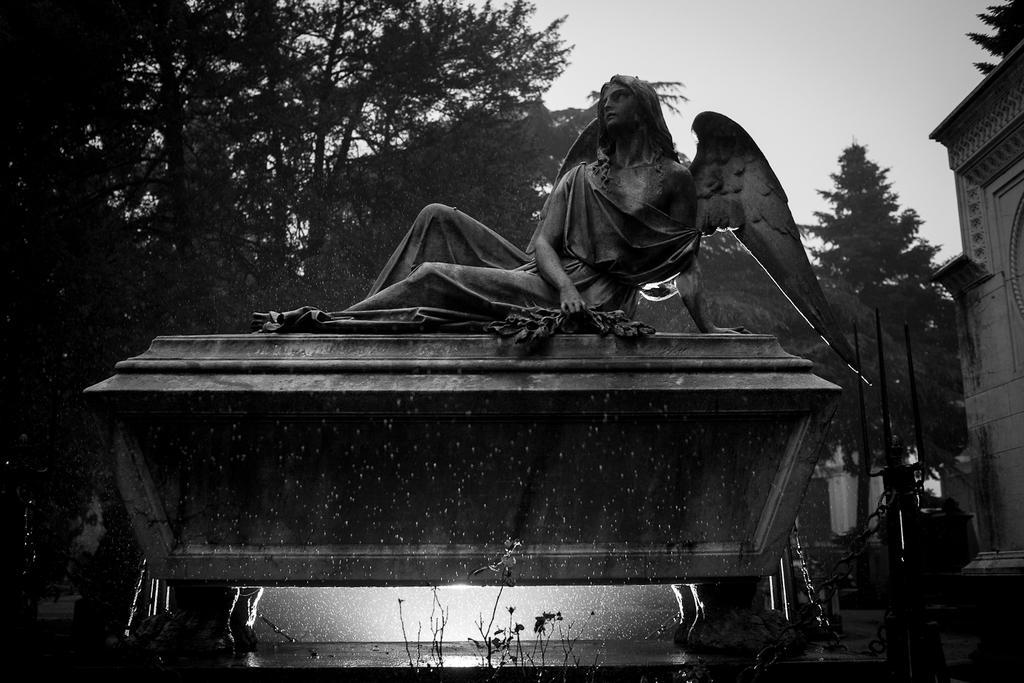In one or two sentences, can you explain what this image depicts? This is a black and white picture. This picture is mainly highlighted with a statue of a women. On the background we can see sky and the trees. On the right side of the picture partial part of the building is visible. 